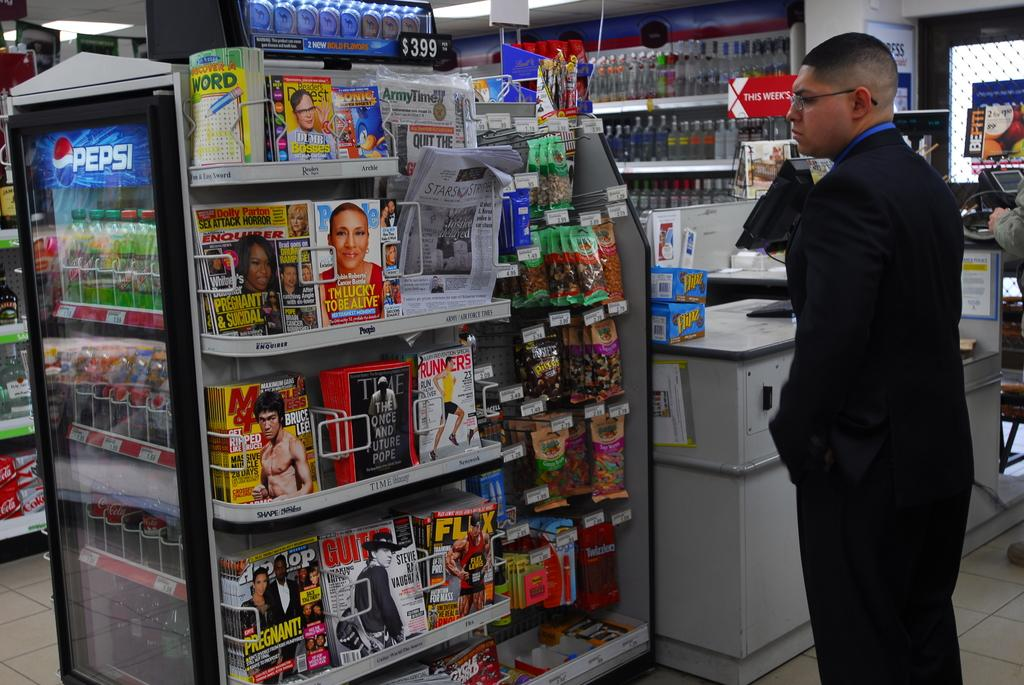<image>
Create a compact narrative representing the image presented. Person standing in line next to a freezer that says "Pepsi". 